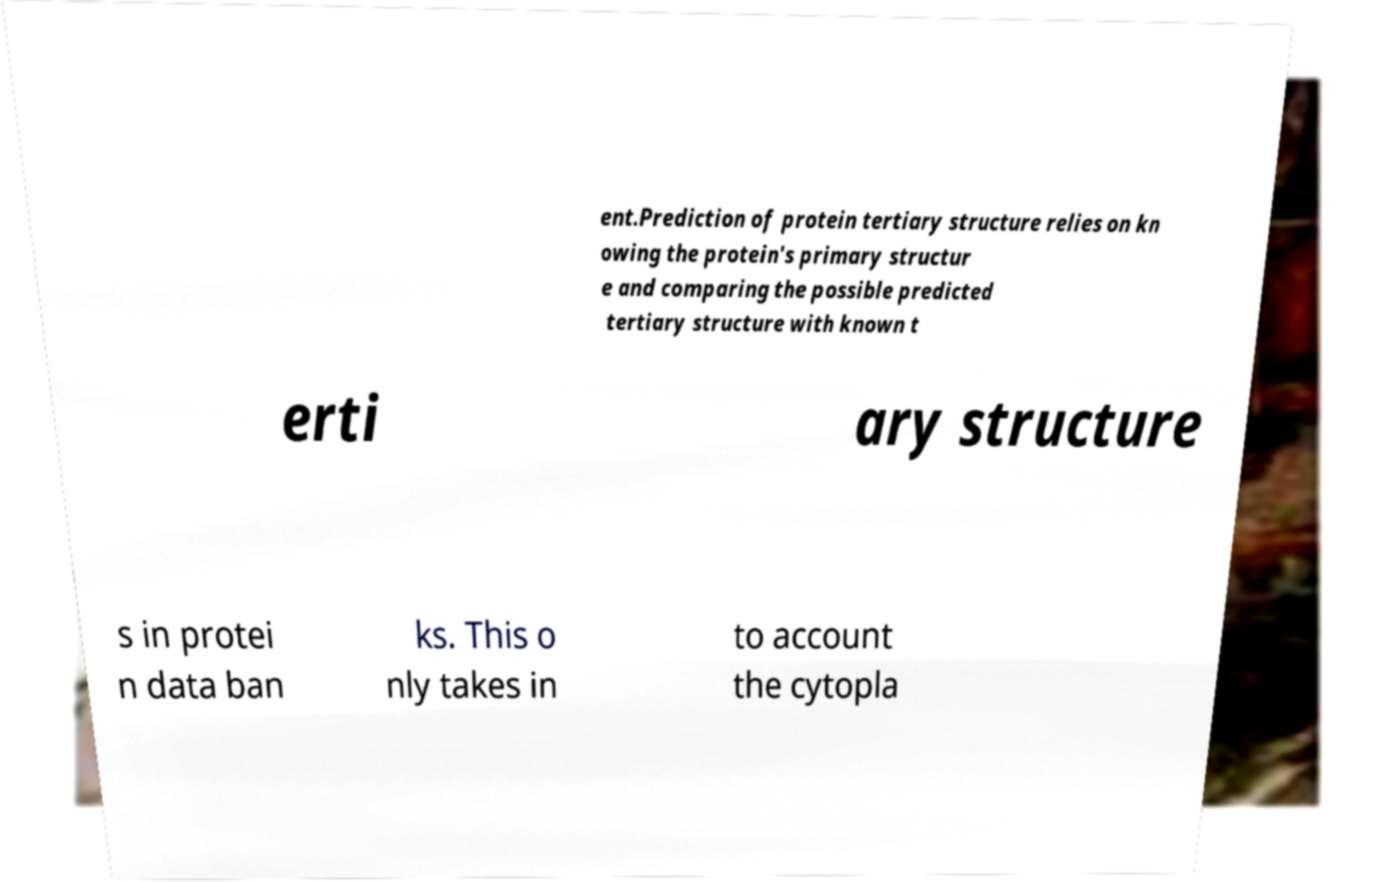For documentation purposes, I need the text within this image transcribed. Could you provide that? ent.Prediction of protein tertiary structure relies on kn owing the protein's primary structur e and comparing the possible predicted tertiary structure with known t erti ary structure s in protei n data ban ks. This o nly takes in to account the cytopla 